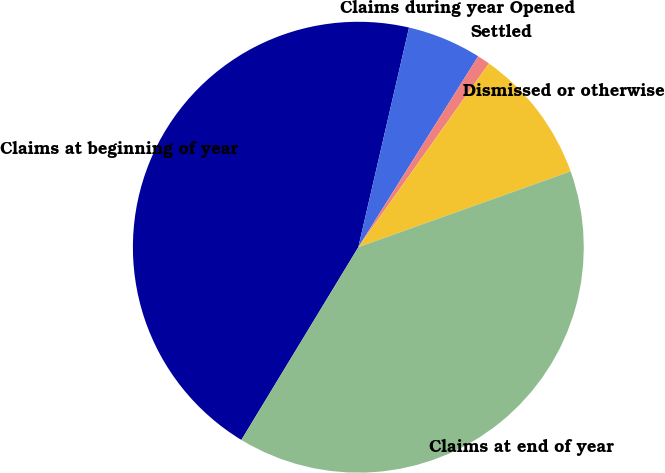Convert chart. <chart><loc_0><loc_0><loc_500><loc_500><pie_chart><fcel>Claims at beginning of year<fcel>Claims during year Opened<fcel>Settled<fcel>Dismissed or otherwise<fcel>Claims at end of year<nl><fcel>44.93%<fcel>5.31%<fcel>0.91%<fcel>9.71%<fcel>39.14%<nl></chart> 